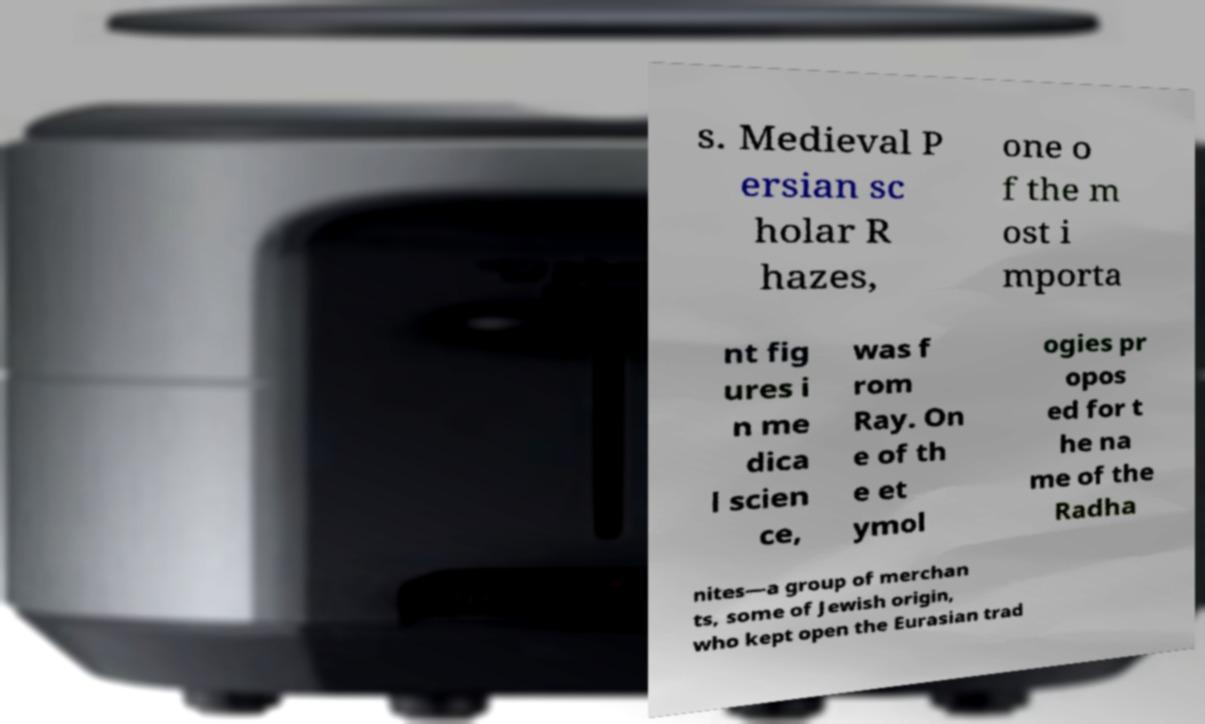Could you extract and type out the text from this image? s. Medieval P ersian sc holar R hazes, one o f the m ost i mporta nt fig ures i n me dica l scien ce, was f rom Ray. On e of th e et ymol ogies pr opos ed for t he na me of the Radha nites—a group of merchan ts, some of Jewish origin, who kept open the Eurasian trad 